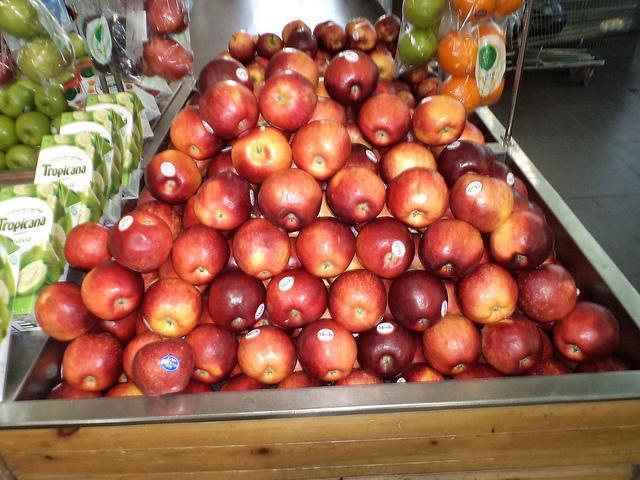How many laptops are there?
Give a very brief answer. 0. 